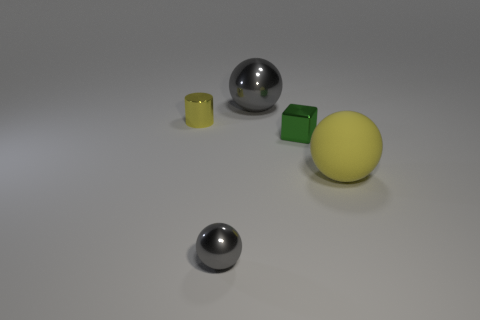Subtract all big shiny spheres. How many spheres are left? 2 Subtract all gray cylinders. How many gray balls are left? 2 Subtract all cyan balls. Subtract all gray cylinders. How many balls are left? 3 Subtract all spheres. How many objects are left? 2 Add 1 tiny green cylinders. How many objects exist? 6 Subtract 0 gray cylinders. How many objects are left? 5 Subtract all small metal things. Subtract all cyan shiny cylinders. How many objects are left? 2 Add 1 yellow things. How many yellow things are left? 3 Add 3 large yellow rubber balls. How many large yellow rubber balls exist? 4 